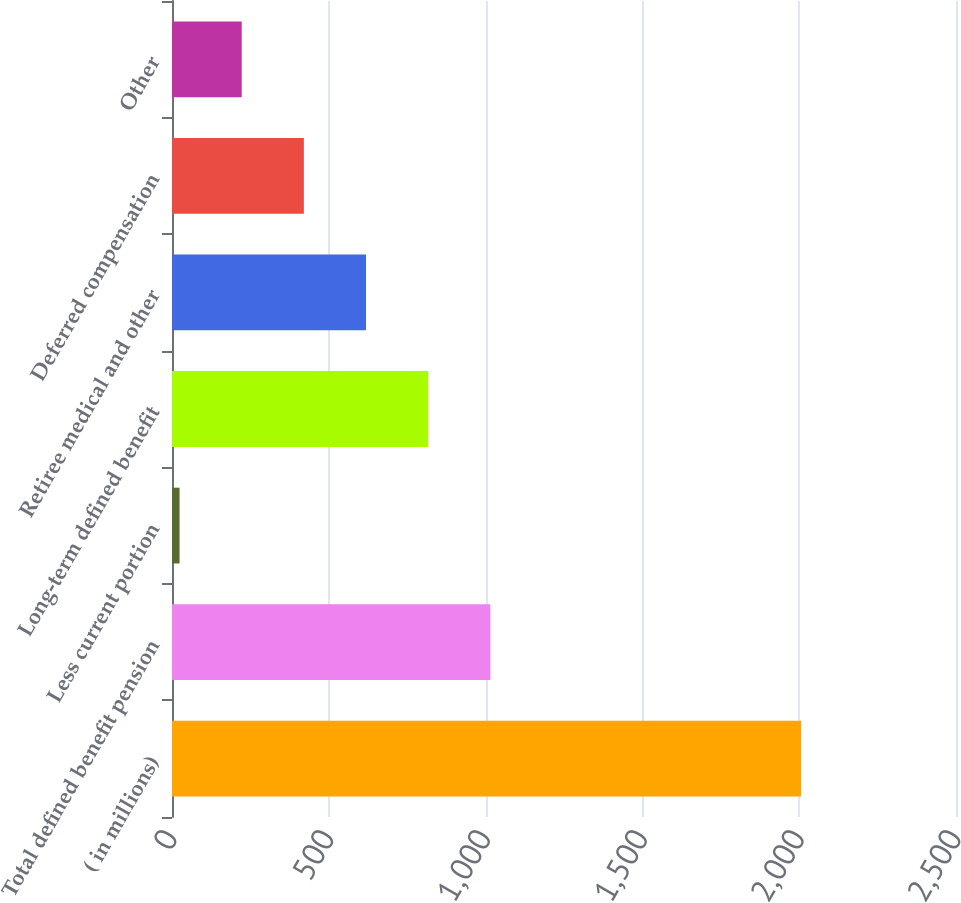Convert chart. <chart><loc_0><loc_0><loc_500><loc_500><bar_chart><fcel>( in millions)<fcel>Total defined benefit pension<fcel>Less current portion<fcel>Long-term defined benefit<fcel>Retiree medical and other<fcel>Deferred compensation<fcel>Other<nl><fcel>2006<fcel>1015.05<fcel>24.1<fcel>816.86<fcel>618.67<fcel>420.48<fcel>222.29<nl></chart> 